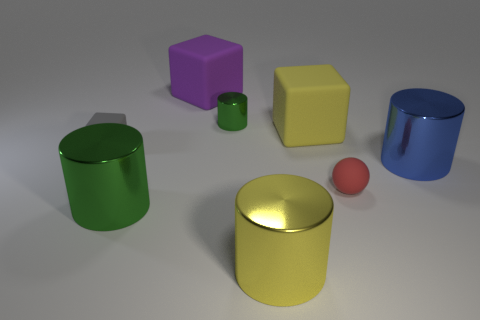What size is the other green thing that is the same shape as the big green object?
Provide a short and direct response. Small. There is a green shiny object that is behind the gray block; how many big cylinders are on the left side of it?
Your answer should be very brief. 1. How many other objects are the same size as the yellow shiny thing?
Your answer should be compact. 4. What size is the metallic cylinder that is the same color as the tiny metallic thing?
Offer a terse response. Large. Does the green object that is in front of the tiny green cylinder have the same shape as the gray rubber object?
Your response must be concise. No. What is the material of the block on the right side of the yellow metallic thing?
Your response must be concise. Rubber. What is the shape of the metal thing that is the same color as the tiny cylinder?
Keep it short and to the point. Cylinder. Is there a big object that has the same material as the tiny cube?
Offer a very short reply. Yes. The yellow metal thing has what size?
Provide a succinct answer. Large. How many gray objects are either tiny blocks or shiny cylinders?
Your answer should be compact. 1. 